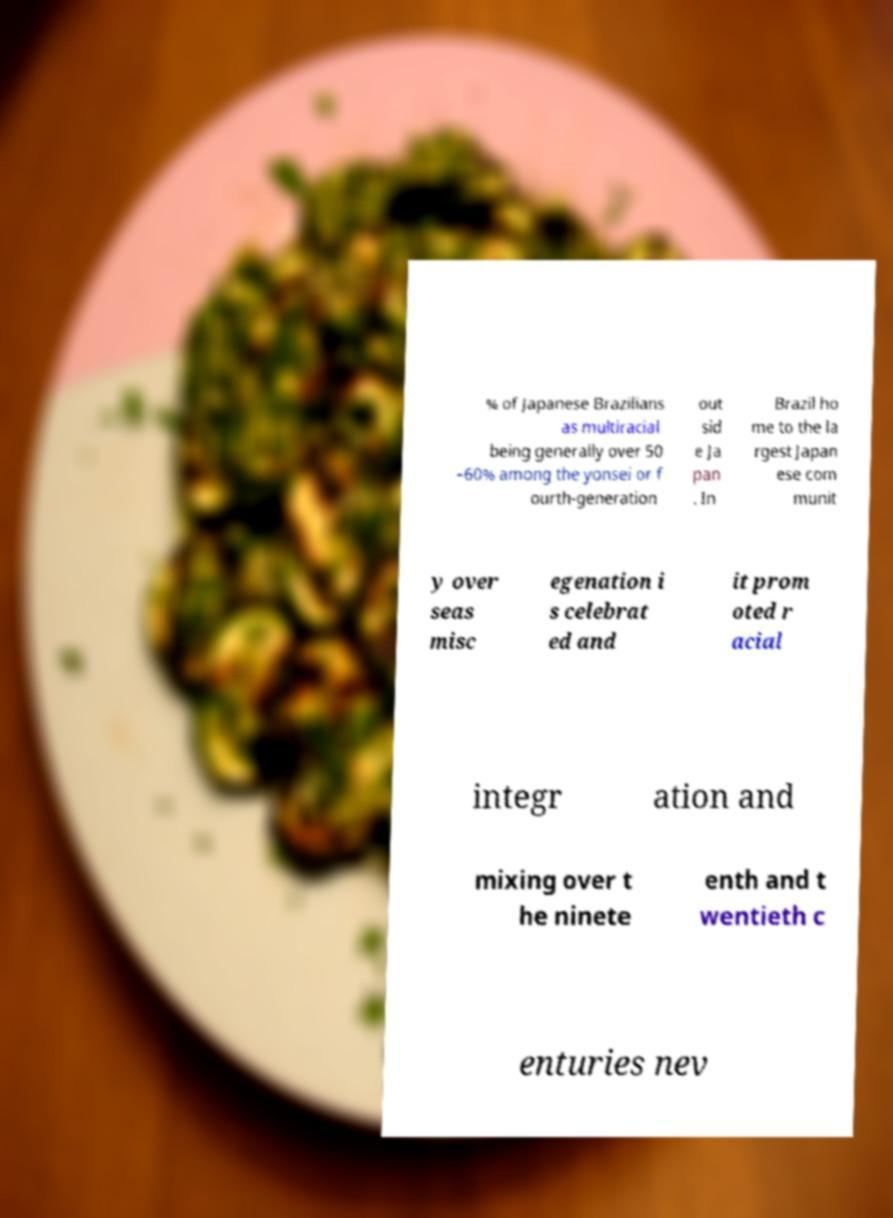Please read and relay the text visible in this image. What does it say? % of Japanese Brazilians as multiracial being generally over 50 –60% among the yonsei or f ourth-generation out sid e Ja pan . In Brazil ho me to the la rgest Japan ese com munit y over seas misc egenation i s celebrat ed and it prom oted r acial integr ation and mixing over t he ninete enth and t wentieth c enturies nev 